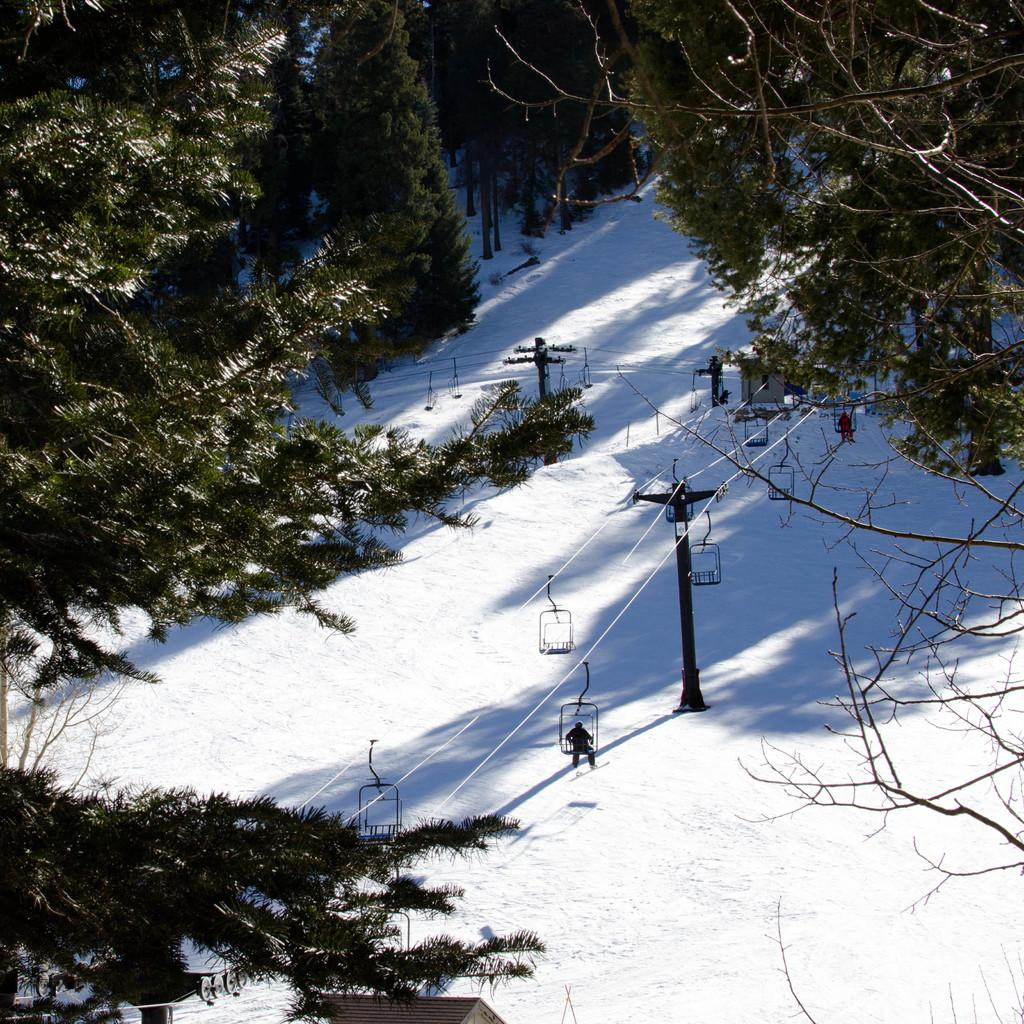What is the primary feature of the environment in the image? The image contains snow. What structures can be seen in the image? There are poles and cable cars visible in the image. What type of vegetation is present in the image? Trees are present in the image. Are there any people in the image? Yes, there is a person is visible in the image. Can you see any ladybugs crawling on the trees in the image? There are no ladybugs visible in the image; it only features snow, poles, cable cars, trees, and a person. 